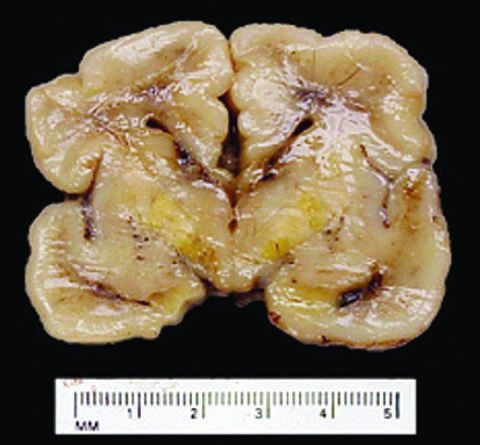does healthy neutrophils with nuclei develop long-term neurologic sequelae?
Answer the question using a single word or phrase. No 